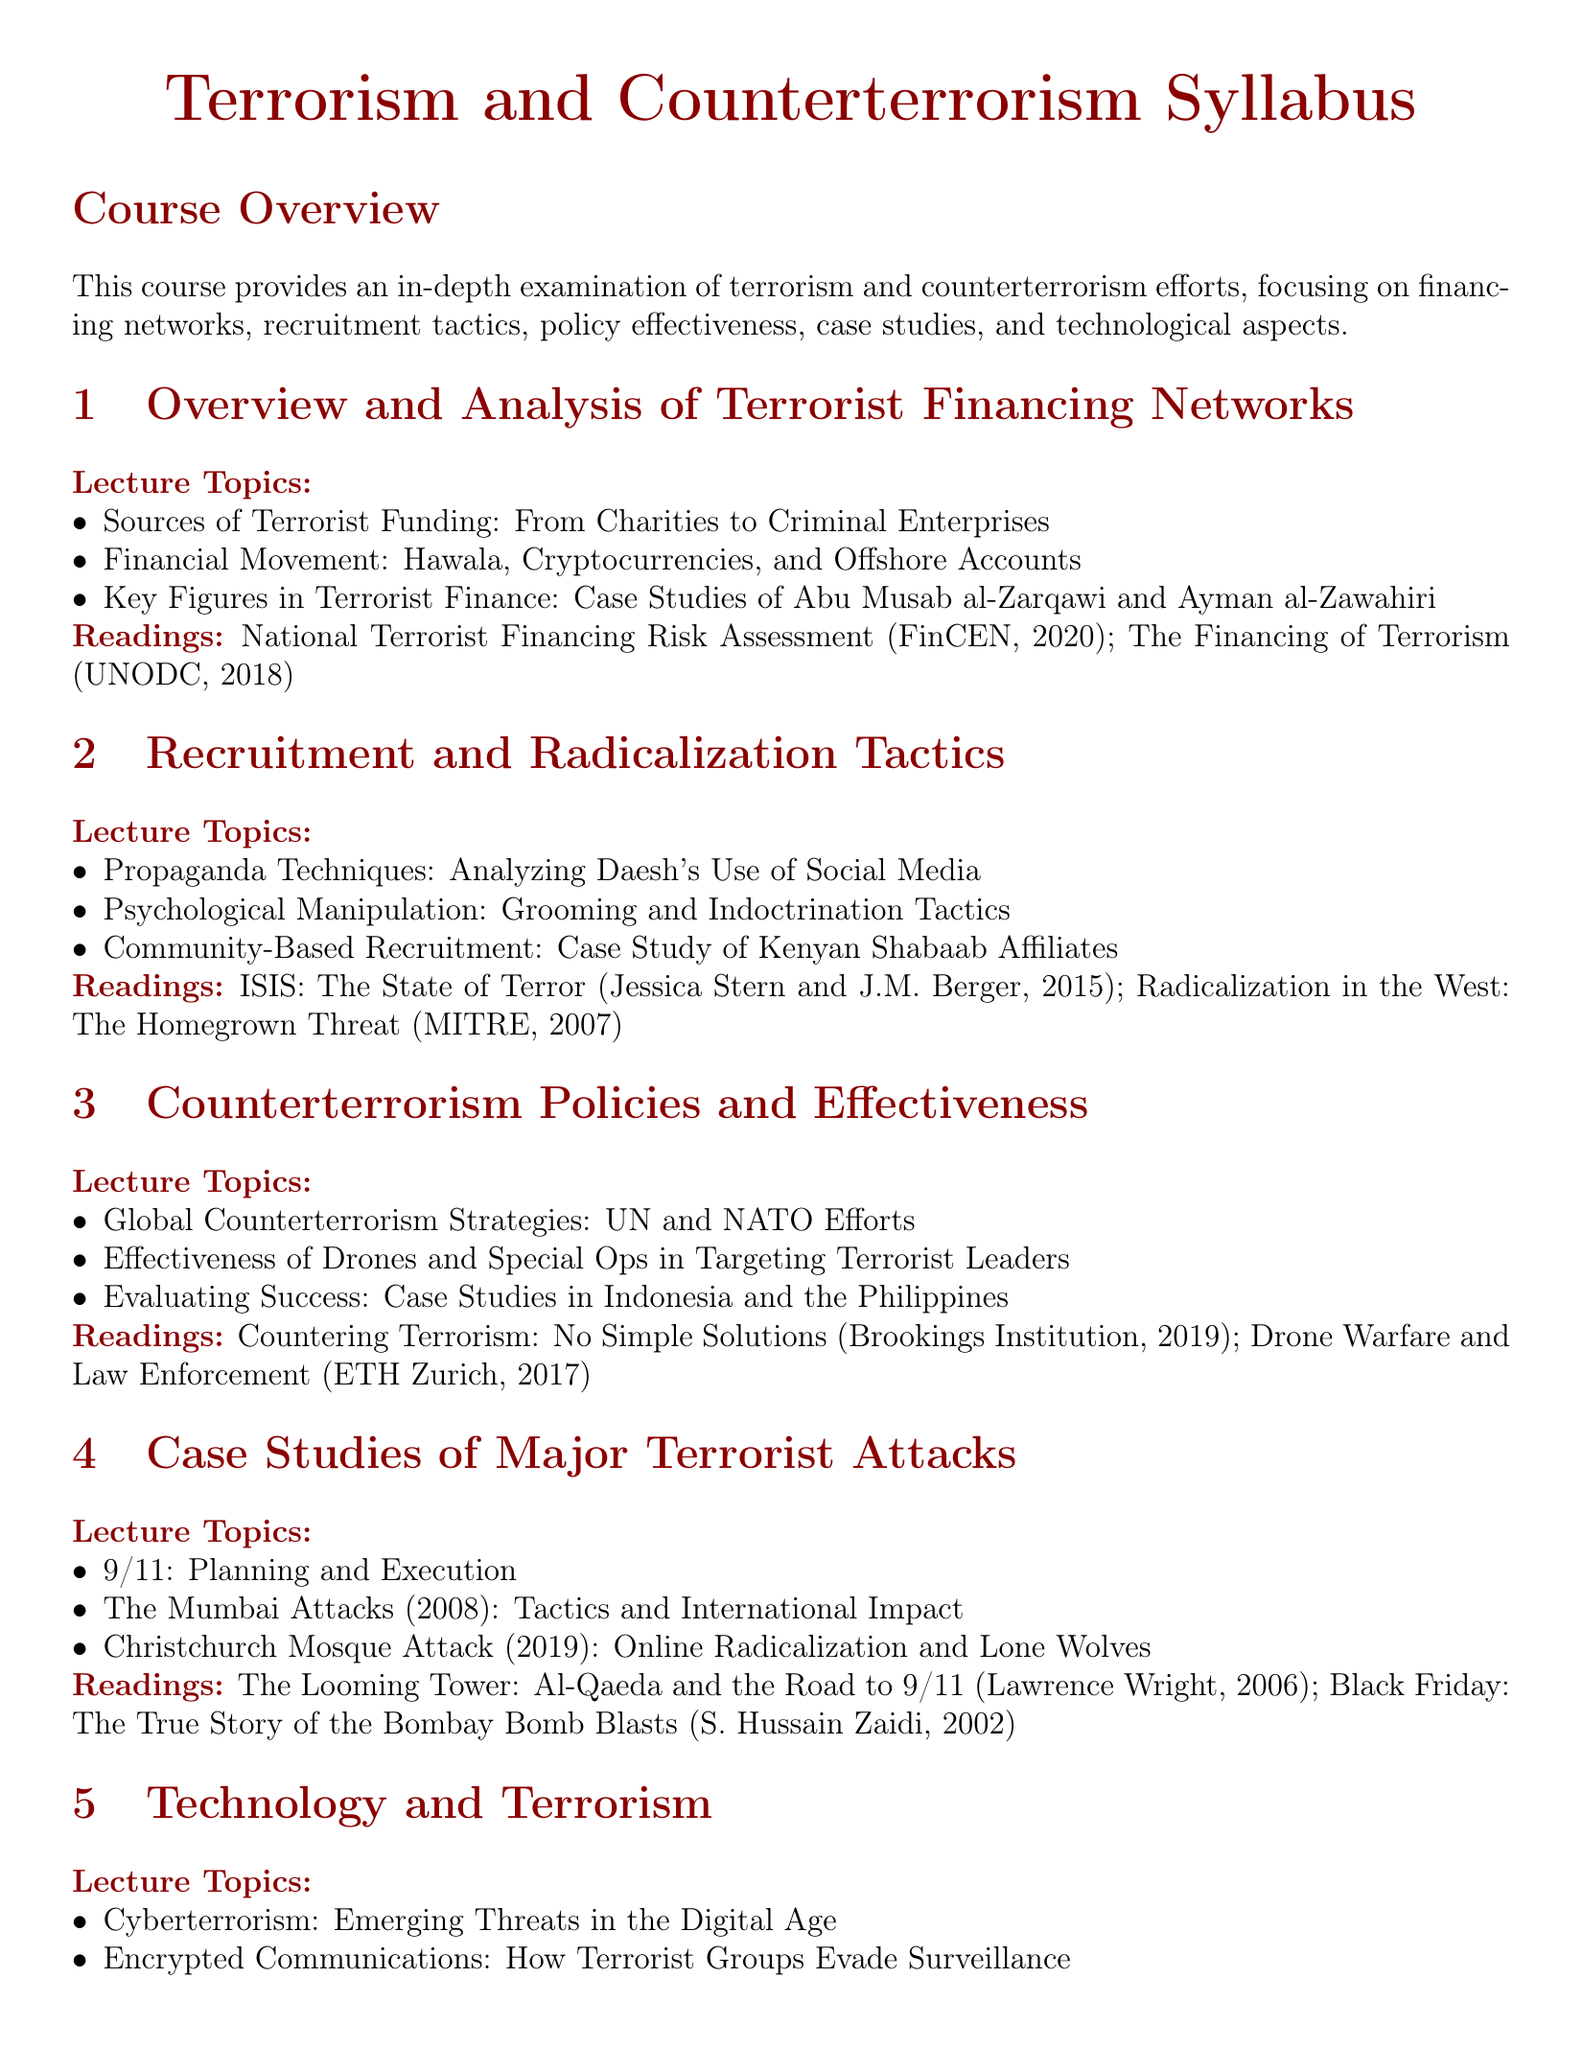what is the title of the course? The title of the course is explicitly stated at the beginning of the document.
Answer: Terrorism and Counterterrorism Syllabus how many lecture topics are listed under "Overview and Analysis of Terrorist Financing Networks"? The number of lecture topics can be found in the section describing the topics under this heading.
Answer: 3 who is mentioned as a key figure in terrorist finance in the syllabus? The document specifies individuals who play a significant role in terrorist finance within this section.
Answer: Abu Musab al-Zarqawi name one reading assigned under "Recruitment and Radicalization Tactics". The syllabus includes specific readings for each section, providing the titles as part of the course materials.
Answer: ISIS: The State of Terror what is a topic covered under "Case Studies of Major Terrorist Attacks"? The section lists significant events analyzed in the context of terrorist attacks.
Answer: 9/11: Planning and Execution which organization’s counterterrorism efforts are reviewed in the syllabus? The document mentions specific global agencies involved in counterterrorism strategies.
Answer: UN what is the total number of course assignments listed in the syllabus? The number of assignments is indicated in the assignments section.
Answer: 5 which technology is discussed in the "Technology and Terrorism" section? The syllabus outlines topics specifically relating to technology's role in terrorism and counterterrorism efforts.
Answer: Cyberterrorism what is the focus of the research paper assignment? The course assignments section gives details on what students are expected to research and write about.
Answer: financial networks of ISIS and Al-Qaeda 